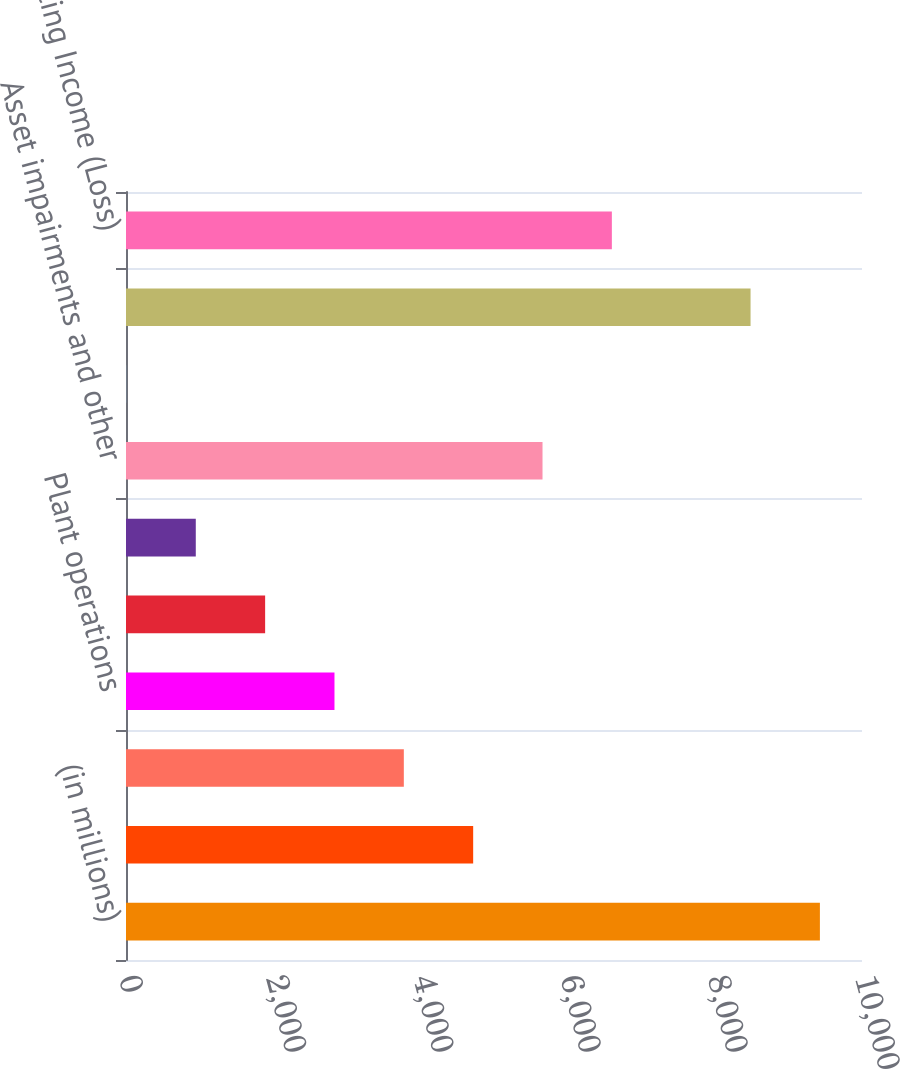Convert chart to OTSL. <chart><loc_0><loc_0><loc_500><loc_500><bar_chart><fcel>(in millions)<fcel>Operating Revenues 1<fcel>Fuel 2<fcel>Plant operations<fcel>Plant operating leases<fcel>Depreciation and amortization<fcel>Asset impairments and other<fcel>Administrative and general<fcel>Total operating expenses<fcel>Operating Income (Loss)<nl><fcel>9428<fcel>4717<fcel>3774.8<fcel>2832.6<fcel>1890.4<fcel>948.2<fcel>5659.2<fcel>6<fcel>8485.8<fcel>6601.4<nl></chart> 